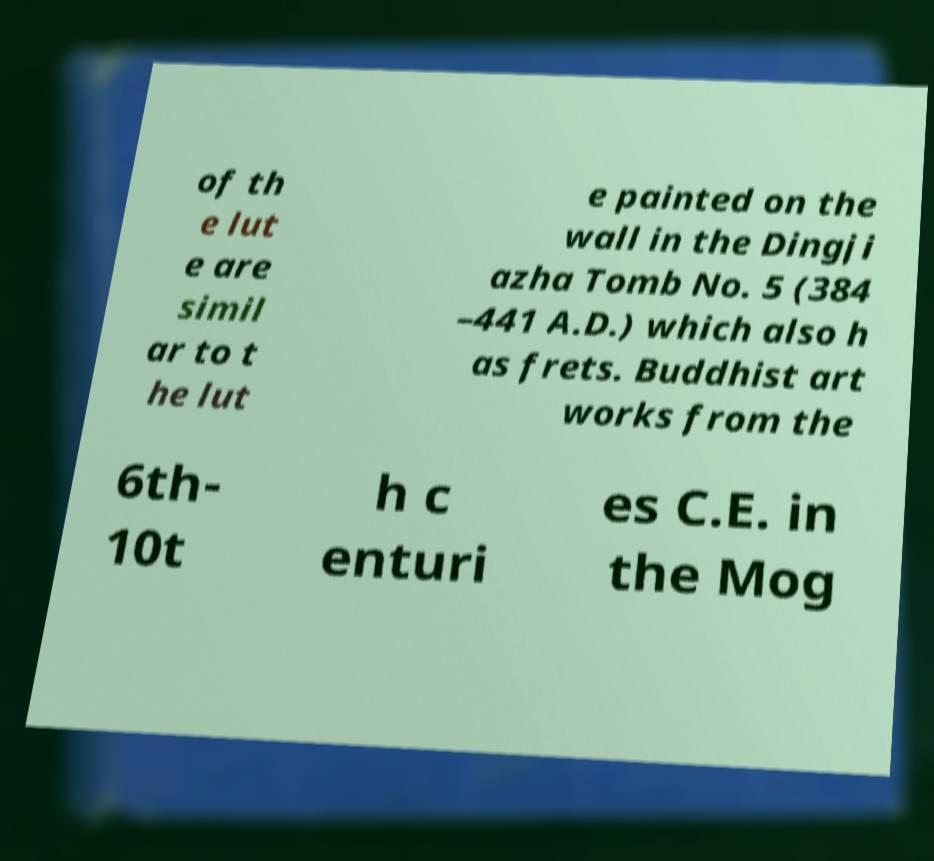Can you accurately transcribe the text from the provided image for me? of th e lut e are simil ar to t he lut e painted on the wall in the Dingji azha Tomb No. 5 (384 –441 A.D.) which also h as frets. Buddhist art works from the 6th- 10t h c enturi es C.E. in the Mog 